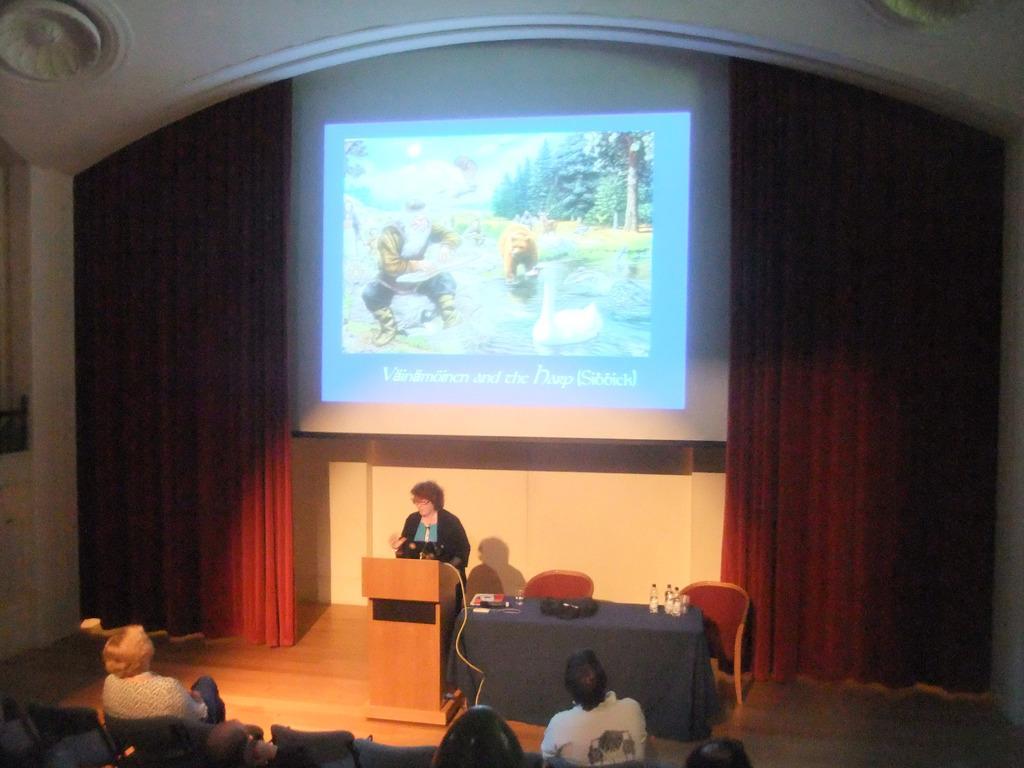Please provide a concise description of this image. In this picture we can see people, here we can see a table, podium, chairs and some objects and in the background we can see a wall, curtain, screen. 